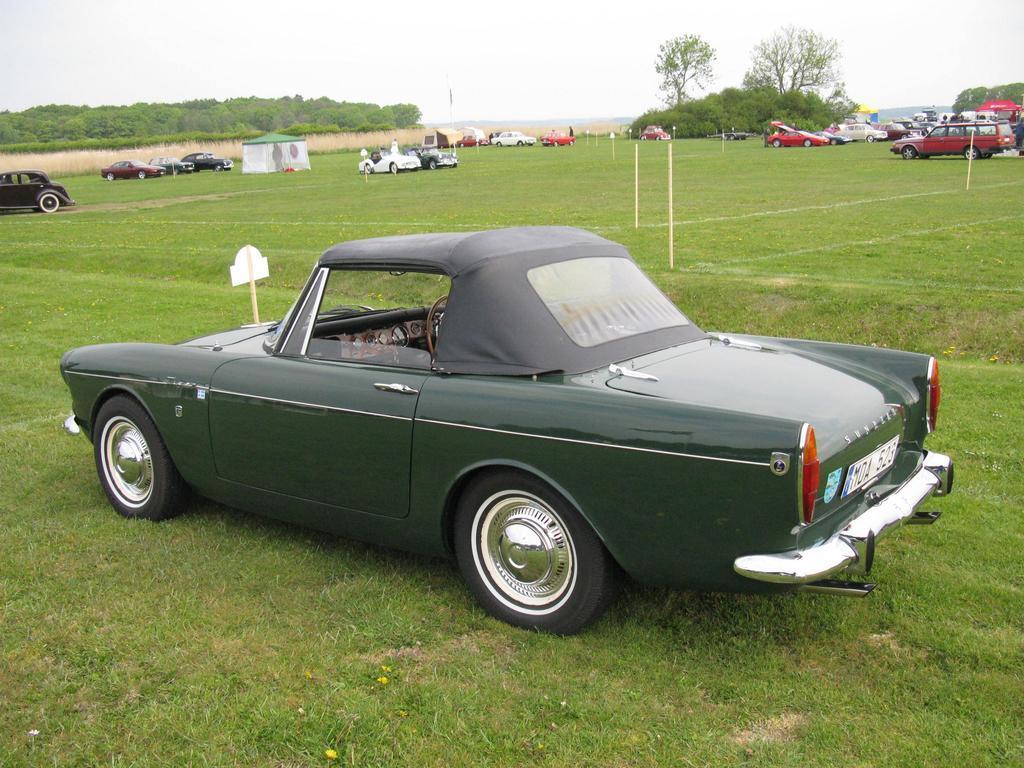Please provide a concise description of this image. There are vehicles in different colors parked on the grass on the ground on which, there are white color lines. In the background, there are tents, plants, trees and there is sky. 